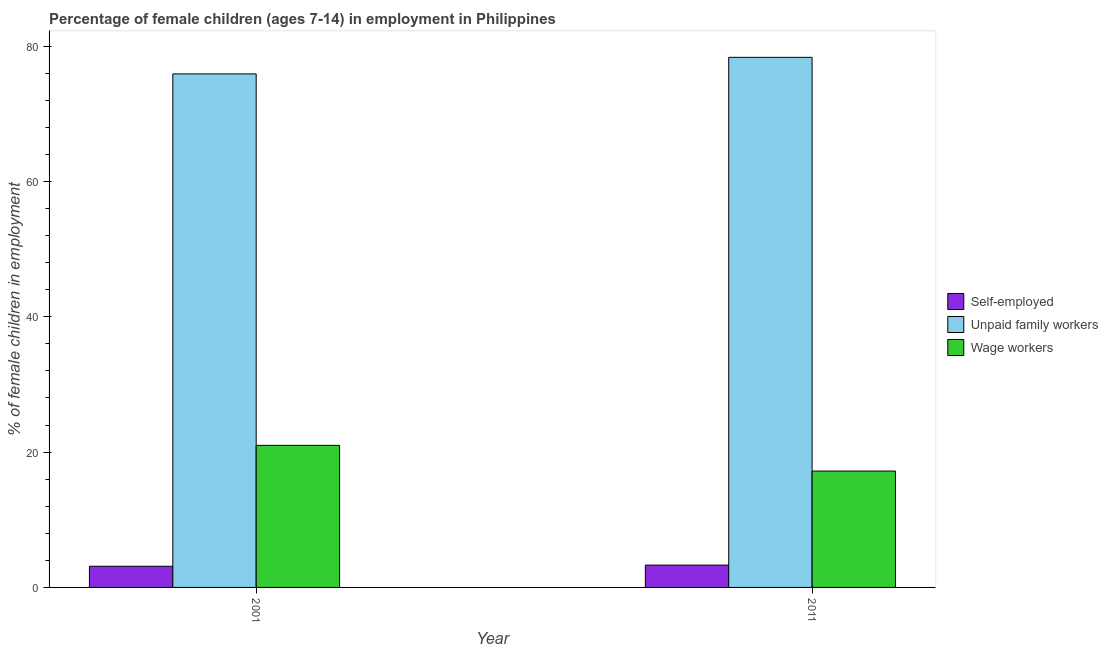How many different coloured bars are there?
Give a very brief answer. 3. How many groups of bars are there?
Offer a terse response. 2. Are the number of bars per tick equal to the number of legend labels?
Keep it short and to the point. Yes. How many bars are there on the 2nd tick from the right?
Make the answer very short. 3. What is the label of the 1st group of bars from the left?
Offer a terse response. 2001. In how many cases, is the number of bars for a given year not equal to the number of legend labels?
Give a very brief answer. 0. Across all years, what is the maximum percentage of children employed as wage workers?
Make the answer very short. 21. Across all years, what is the minimum percentage of children employed as wage workers?
Your answer should be very brief. 17.2. In which year was the percentage of children employed as wage workers maximum?
Keep it short and to the point. 2001. In which year was the percentage of self employed children minimum?
Offer a terse response. 2001. What is the total percentage of children employed as unpaid family workers in the graph?
Provide a succinct answer. 154.25. What is the difference between the percentage of children employed as unpaid family workers in 2001 and that in 2011?
Ensure brevity in your answer.  -2.45. What is the difference between the percentage of children employed as unpaid family workers in 2011 and the percentage of self employed children in 2001?
Ensure brevity in your answer.  2.45. What is the average percentage of self employed children per year?
Your answer should be very brief. 3.21. In the year 2011, what is the difference between the percentage of self employed children and percentage of children employed as unpaid family workers?
Your response must be concise. 0. What is the ratio of the percentage of children employed as unpaid family workers in 2001 to that in 2011?
Provide a succinct answer. 0.97. In how many years, is the percentage of children employed as unpaid family workers greater than the average percentage of children employed as unpaid family workers taken over all years?
Offer a very short reply. 1. What does the 1st bar from the left in 2001 represents?
Provide a short and direct response. Self-employed. What does the 3rd bar from the right in 2011 represents?
Your answer should be compact. Self-employed. Is it the case that in every year, the sum of the percentage of self employed children and percentage of children employed as unpaid family workers is greater than the percentage of children employed as wage workers?
Ensure brevity in your answer.  Yes. How many bars are there?
Provide a short and direct response. 6. Are all the bars in the graph horizontal?
Offer a very short reply. No. How many years are there in the graph?
Give a very brief answer. 2. What is the difference between two consecutive major ticks on the Y-axis?
Keep it short and to the point. 20. Does the graph contain any zero values?
Give a very brief answer. No. Where does the legend appear in the graph?
Offer a terse response. Center right. How many legend labels are there?
Keep it short and to the point. 3. How are the legend labels stacked?
Keep it short and to the point. Vertical. What is the title of the graph?
Your answer should be compact. Percentage of female children (ages 7-14) in employment in Philippines. What is the label or title of the X-axis?
Your answer should be compact. Year. What is the label or title of the Y-axis?
Keep it short and to the point. % of female children in employment. What is the % of female children in employment in Self-employed in 2001?
Provide a short and direct response. 3.13. What is the % of female children in employment of Unpaid family workers in 2001?
Provide a short and direct response. 75.9. What is the % of female children in employment in Wage workers in 2001?
Provide a succinct answer. 21. What is the % of female children in employment of Self-employed in 2011?
Give a very brief answer. 3.3. What is the % of female children in employment in Unpaid family workers in 2011?
Your answer should be very brief. 78.35. Across all years, what is the maximum % of female children in employment in Self-employed?
Make the answer very short. 3.3. Across all years, what is the maximum % of female children in employment of Unpaid family workers?
Offer a very short reply. 78.35. Across all years, what is the maximum % of female children in employment of Wage workers?
Your response must be concise. 21. Across all years, what is the minimum % of female children in employment in Self-employed?
Provide a succinct answer. 3.13. Across all years, what is the minimum % of female children in employment in Unpaid family workers?
Make the answer very short. 75.9. What is the total % of female children in employment in Self-employed in the graph?
Provide a short and direct response. 6.43. What is the total % of female children in employment of Unpaid family workers in the graph?
Provide a short and direct response. 154.25. What is the total % of female children in employment in Wage workers in the graph?
Provide a succinct answer. 38.2. What is the difference between the % of female children in employment of Self-employed in 2001 and that in 2011?
Keep it short and to the point. -0.17. What is the difference between the % of female children in employment in Unpaid family workers in 2001 and that in 2011?
Offer a very short reply. -2.45. What is the difference between the % of female children in employment of Self-employed in 2001 and the % of female children in employment of Unpaid family workers in 2011?
Make the answer very short. -75.22. What is the difference between the % of female children in employment in Self-employed in 2001 and the % of female children in employment in Wage workers in 2011?
Your answer should be very brief. -14.07. What is the difference between the % of female children in employment in Unpaid family workers in 2001 and the % of female children in employment in Wage workers in 2011?
Your answer should be compact. 58.7. What is the average % of female children in employment of Self-employed per year?
Provide a short and direct response. 3.21. What is the average % of female children in employment of Unpaid family workers per year?
Make the answer very short. 77.12. What is the average % of female children in employment of Wage workers per year?
Provide a short and direct response. 19.1. In the year 2001, what is the difference between the % of female children in employment in Self-employed and % of female children in employment in Unpaid family workers?
Your answer should be very brief. -72.77. In the year 2001, what is the difference between the % of female children in employment of Self-employed and % of female children in employment of Wage workers?
Keep it short and to the point. -17.87. In the year 2001, what is the difference between the % of female children in employment of Unpaid family workers and % of female children in employment of Wage workers?
Offer a very short reply. 54.9. In the year 2011, what is the difference between the % of female children in employment in Self-employed and % of female children in employment in Unpaid family workers?
Provide a succinct answer. -75.05. In the year 2011, what is the difference between the % of female children in employment in Unpaid family workers and % of female children in employment in Wage workers?
Give a very brief answer. 61.15. What is the ratio of the % of female children in employment in Self-employed in 2001 to that in 2011?
Your answer should be compact. 0.95. What is the ratio of the % of female children in employment in Unpaid family workers in 2001 to that in 2011?
Make the answer very short. 0.97. What is the ratio of the % of female children in employment of Wage workers in 2001 to that in 2011?
Give a very brief answer. 1.22. What is the difference between the highest and the second highest % of female children in employment in Self-employed?
Provide a short and direct response. 0.17. What is the difference between the highest and the second highest % of female children in employment of Unpaid family workers?
Ensure brevity in your answer.  2.45. What is the difference between the highest and the lowest % of female children in employment in Self-employed?
Your answer should be compact. 0.17. What is the difference between the highest and the lowest % of female children in employment in Unpaid family workers?
Give a very brief answer. 2.45. 